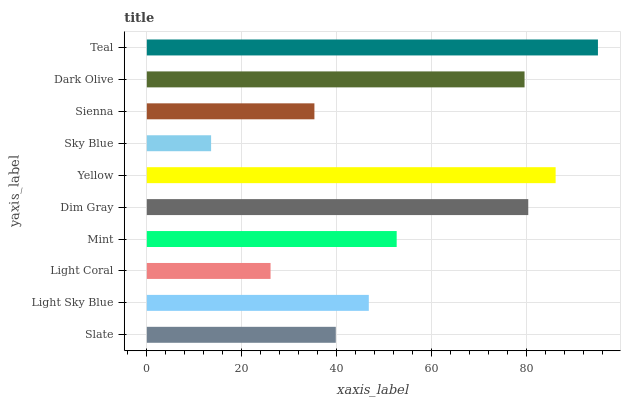Is Sky Blue the minimum?
Answer yes or no. Yes. Is Teal the maximum?
Answer yes or no. Yes. Is Light Sky Blue the minimum?
Answer yes or no. No. Is Light Sky Blue the maximum?
Answer yes or no. No. Is Light Sky Blue greater than Slate?
Answer yes or no. Yes. Is Slate less than Light Sky Blue?
Answer yes or no. Yes. Is Slate greater than Light Sky Blue?
Answer yes or no. No. Is Light Sky Blue less than Slate?
Answer yes or no. No. Is Mint the high median?
Answer yes or no. Yes. Is Light Sky Blue the low median?
Answer yes or no. Yes. Is Light Sky Blue the high median?
Answer yes or no. No. Is Light Coral the low median?
Answer yes or no. No. 